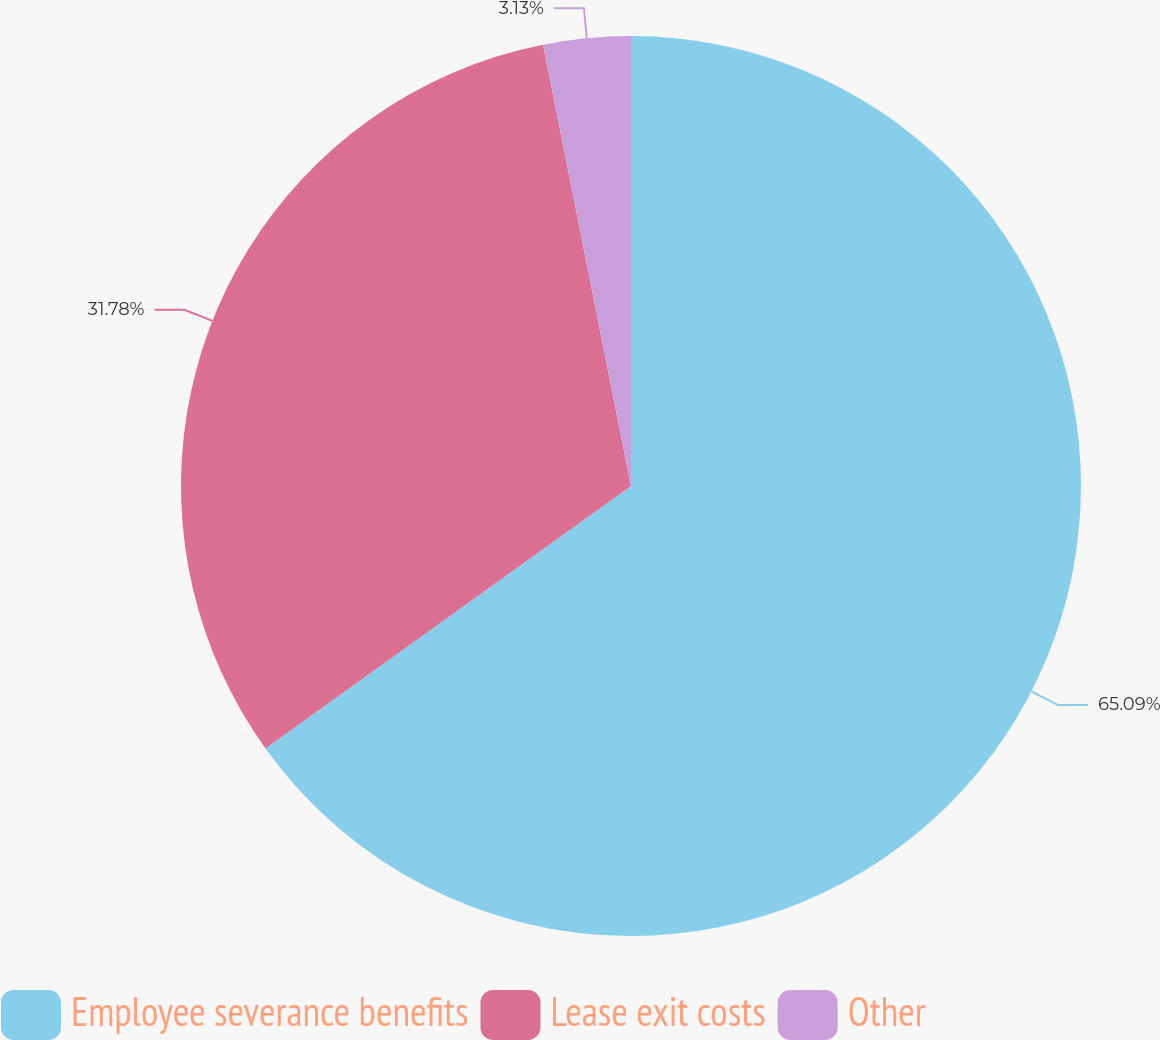<chart> <loc_0><loc_0><loc_500><loc_500><pie_chart><fcel>Employee severance benefits<fcel>Lease exit costs<fcel>Other<nl><fcel>65.09%<fcel>31.78%<fcel>3.13%<nl></chart> 